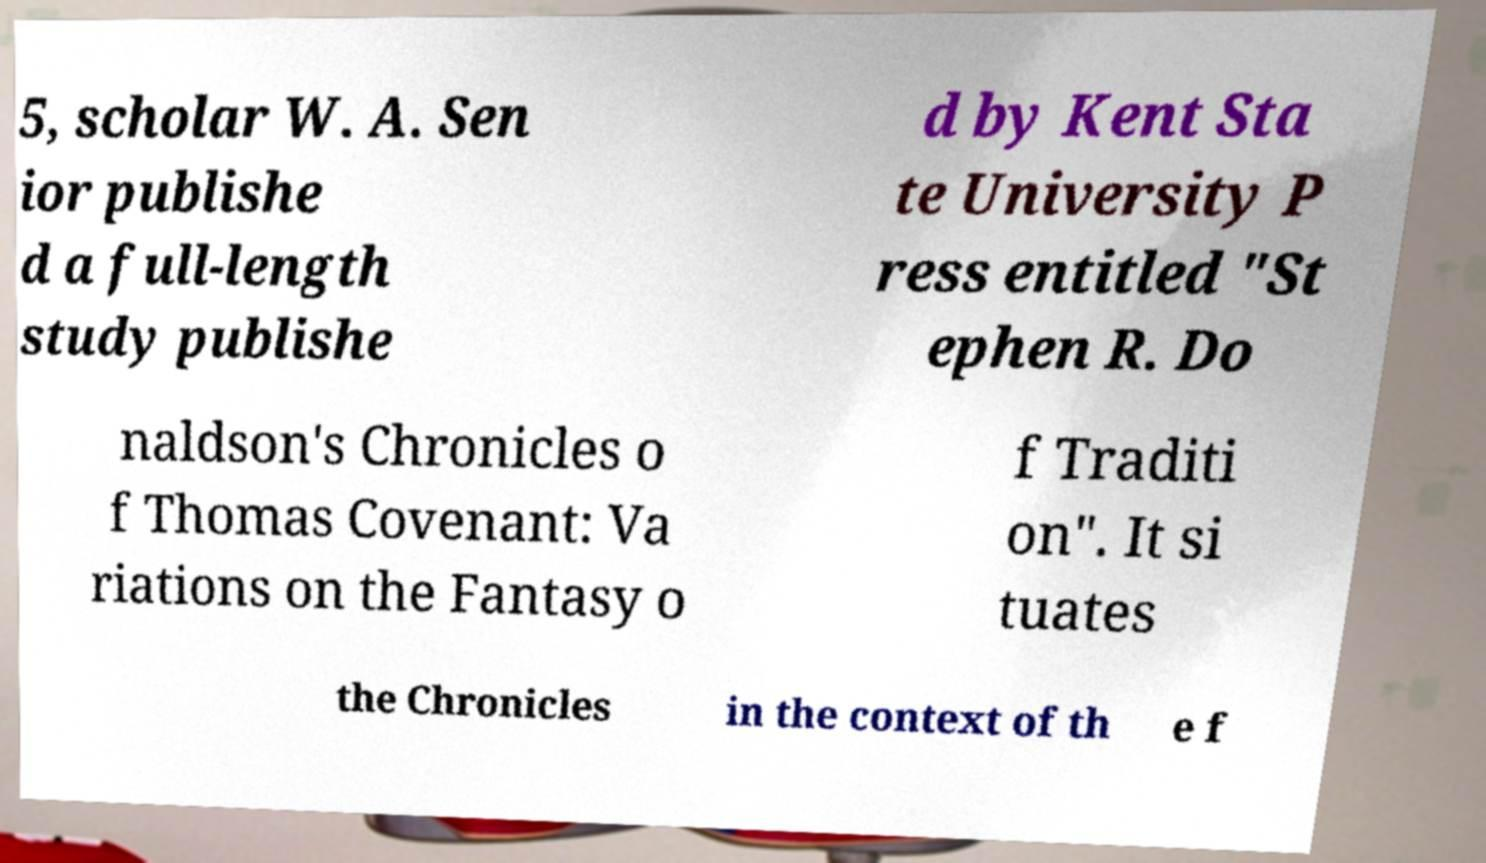Could you assist in decoding the text presented in this image and type it out clearly? 5, scholar W. A. Sen ior publishe d a full-length study publishe d by Kent Sta te University P ress entitled "St ephen R. Do naldson's Chronicles o f Thomas Covenant: Va riations on the Fantasy o f Traditi on". It si tuates the Chronicles in the context of th e f 